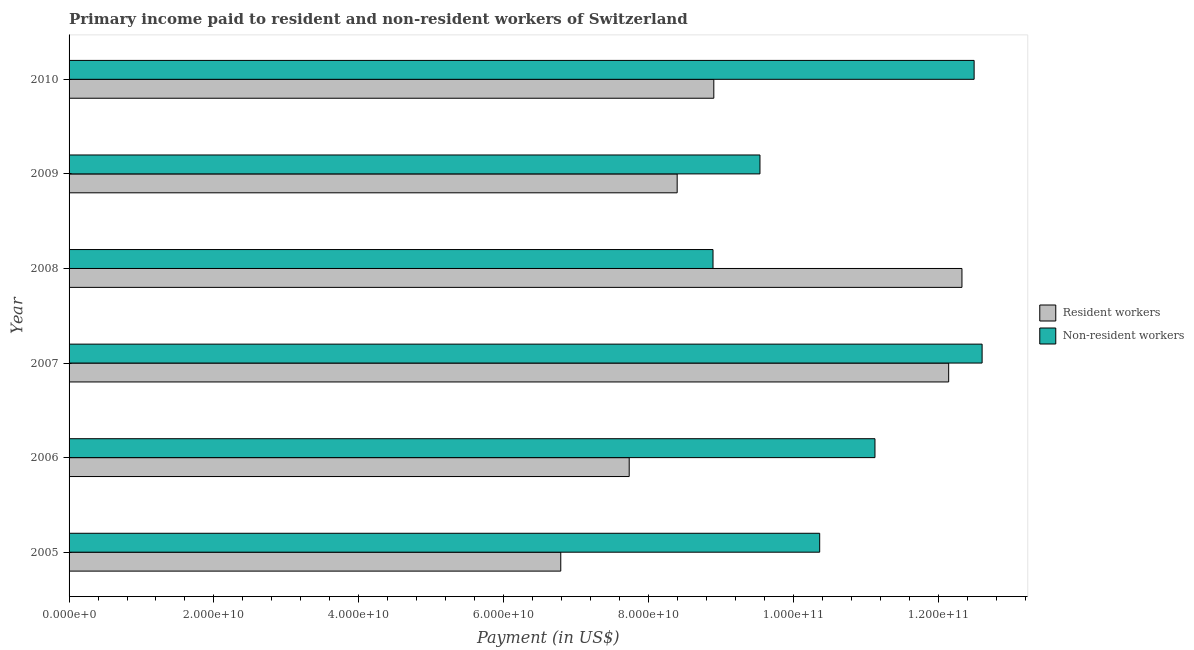How many different coloured bars are there?
Offer a terse response. 2. How many groups of bars are there?
Keep it short and to the point. 6. How many bars are there on the 5th tick from the top?
Your response must be concise. 2. What is the label of the 6th group of bars from the top?
Keep it short and to the point. 2005. What is the payment made to non-resident workers in 2008?
Provide a short and direct response. 8.89e+1. Across all years, what is the maximum payment made to resident workers?
Ensure brevity in your answer.  1.23e+11. Across all years, what is the minimum payment made to resident workers?
Your answer should be very brief. 6.79e+1. In which year was the payment made to non-resident workers maximum?
Ensure brevity in your answer.  2007. In which year was the payment made to resident workers minimum?
Give a very brief answer. 2005. What is the total payment made to non-resident workers in the graph?
Your answer should be very brief. 6.50e+11. What is the difference between the payment made to non-resident workers in 2007 and that in 2008?
Ensure brevity in your answer.  3.72e+1. What is the difference between the payment made to non-resident workers in 2006 and the payment made to resident workers in 2010?
Offer a very short reply. 2.22e+1. What is the average payment made to non-resident workers per year?
Keep it short and to the point. 1.08e+11. In the year 2006, what is the difference between the payment made to resident workers and payment made to non-resident workers?
Your response must be concise. -3.39e+1. In how many years, is the payment made to resident workers greater than 28000000000 US$?
Make the answer very short. 6. What is the ratio of the payment made to resident workers in 2006 to that in 2008?
Keep it short and to the point. 0.63. Is the difference between the payment made to non-resident workers in 2005 and 2007 greater than the difference between the payment made to resident workers in 2005 and 2007?
Provide a short and direct response. Yes. What is the difference between the highest and the second highest payment made to non-resident workers?
Offer a very short reply. 1.10e+09. What is the difference between the highest and the lowest payment made to non-resident workers?
Your answer should be very brief. 3.72e+1. What does the 2nd bar from the top in 2006 represents?
Offer a very short reply. Resident workers. What does the 1st bar from the bottom in 2009 represents?
Your answer should be very brief. Resident workers. How many bars are there?
Keep it short and to the point. 12. Are all the bars in the graph horizontal?
Provide a short and direct response. Yes. Does the graph contain any zero values?
Offer a terse response. No. Does the graph contain grids?
Make the answer very short. No. How many legend labels are there?
Your answer should be compact. 2. How are the legend labels stacked?
Your answer should be compact. Vertical. What is the title of the graph?
Keep it short and to the point. Primary income paid to resident and non-resident workers of Switzerland. What is the label or title of the X-axis?
Provide a succinct answer. Payment (in US$). What is the Payment (in US$) in Resident workers in 2005?
Provide a succinct answer. 6.79e+1. What is the Payment (in US$) of Non-resident workers in 2005?
Keep it short and to the point. 1.04e+11. What is the Payment (in US$) in Resident workers in 2006?
Your response must be concise. 7.73e+1. What is the Payment (in US$) in Non-resident workers in 2006?
Ensure brevity in your answer.  1.11e+11. What is the Payment (in US$) of Resident workers in 2007?
Provide a succinct answer. 1.21e+11. What is the Payment (in US$) in Non-resident workers in 2007?
Keep it short and to the point. 1.26e+11. What is the Payment (in US$) in Resident workers in 2008?
Your answer should be compact. 1.23e+11. What is the Payment (in US$) of Non-resident workers in 2008?
Keep it short and to the point. 8.89e+1. What is the Payment (in US$) in Resident workers in 2009?
Your response must be concise. 8.40e+1. What is the Payment (in US$) in Non-resident workers in 2009?
Provide a succinct answer. 9.54e+1. What is the Payment (in US$) of Resident workers in 2010?
Ensure brevity in your answer.  8.90e+1. What is the Payment (in US$) of Non-resident workers in 2010?
Your answer should be very brief. 1.25e+11. Across all years, what is the maximum Payment (in US$) of Resident workers?
Provide a short and direct response. 1.23e+11. Across all years, what is the maximum Payment (in US$) in Non-resident workers?
Ensure brevity in your answer.  1.26e+11. Across all years, what is the minimum Payment (in US$) in Resident workers?
Your answer should be compact. 6.79e+1. Across all years, what is the minimum Payment (in US$) in Non-resident workers?
Keep it short and to the point. 8.89e+1. What is the total Payment (in US$) in Resident workers in the graph?
Give a very brief answer. 5.63e+11. What is the total Payment (in US$) in Non-resident workers in the graph?
Offer a very short reply. 6.50e+11. What is the difference between the Payment (in US$) in Resident workers in 2005 and that in 2006?
Your answer should be compact. -9.45e+09. What is the difference between the Payment (in US$) in Non-resident workers in 2005 and that in 2006?
Ensure brevity in your answer.  -7.63e+09. What is the difference between the Payment (in US$) in Resident workers in 2005 and that in 2007?
Provide a succinct answer. -5.36e+1. What is the difference between the Payment (in US$) in Non-resident workers in 2005 and that in 2007?
Your answer should be very brief. -2.24e+1. What is the difference between the Payment (in US$) in Resident workers in 2005 and that in 2008?
Your response must be concise. -5.54e+1. What is the difference between the Payment (in US$) of Non-resident workers in 2005 and that in 2008?
Your response must be concise. 1.47e+1. What is the difference between the Payment (in US$) of Resident workers in 2005 and that in 2009?
Your response must be concise. -1.61e+1. What is the difference between the Payment (in US$) in Non-resident workers in 2005 and that in 2009?
Ensure brevity in your answer.  8.24e+09. What is the difference between the Payment (in US$) of Resident workers in 2005 and that in 2010?
Provide a succinct answer. -2.11e+1. What is the difference between the Payment (in US$) in Non-resident workers in 2005 and that in 2010?
Provide a short and direct response. -2.13e+1. What is the difference between the Payment (in US$) of Resident workers in 2006 and that in 2007?
Keep it short and to the point. -4.41e+1. What is the difference between the Payment (in US$) in Non-resident workers in 2006 and that in 2007?
Your response must be concise. -1.48e+1. What is the difference between the Payment (in US$) of Resident workers in 2006 and that in 2008?
Keep it short and to the point. -4.59e+1. What is the difference between the Payment (in US$) of Non-resident workers in 2006 and that in 2008?
Keep it short and to the point. 2.24e+1. What is the difference between the Payment (in US$) of Resident workers in 2006 and that in 2009?
Ensure brevity in your answer.  -6.62e+09. What is the difference between the Payment (in US$) in Non-resident workers in 2006 and that in 2009?
Give a very brief answer. 1.59e+1. What is the difference between the Payment (in US$) of Resident workers in 2006 and that in 2010?
Provide a short and direct response. -1.17e+1. What is the difference between the Payment (in US$) in Non-resident workers in 2006 and that in 2010?
Offer a terse response. -1.37e+1. What is the difference between the Payment (in US$) in Resident workers in 2007 and that in 2008?
Offer a very short reply. -1.83e+09. What is the difference between the Payment (in US$) in Non-resident workers in 2007 and that in 2008?
Give a very brief answer. 3.72e+1. What is the difference between the Payment (in US$) of Resident workers in 2007 and that in 2009?
Ensure brevity in your answer.  3.75e+1. What is the difference between the Payment (in US$) in Non-resident workers in 2007 and that in 2009?
Offer a terse response. 3.07e+1. What is the difference between the Payment (in US$) of Resident workers in 2007 and that in 2010?
Give a very brief answer. 3.24e+1. What is the difference between the Payment (in US$) in Non-resident workers in 2007 and that in 2010?
Offer a terse response. 1.10e+09. What is the difference between the Payment (in US$) of Resident workers in 2008 and that in 2009?
Provide a short and direct response. 3.93e+1. What is the difference between the Payment (in US$) of Non-resident workers in 2008 and that in 2009?
Give a very brief answer. -6.48e+09. What is the difference between the Payment (in US$) of Resident workers in 2008 and that in 2010?
Keep it short and to the point. 3.43e+1. What is the difference between the Payment (in US$) of Non-resident workers in 2008 and that in 2010?
Give a very brief answer. -3.60e+1. What is the difference between the Payment (in US$) in Resident workers in 2009 and that in 2010?
Provide a short and direct response. -5.06e+09. What is the difference between the Payment (in US$) of Non-resident workers in 2009 and that in 2010?
Keep it short and to the point. -2.96e+1. What is the difference between the Payment (in US$) of Resident workers in 2005 and the Payment (in US$) of Non-resident workers in 2006?
Provide a short and direct response. -4.34e+1. What is the difference between the Payment (in US$) of Resident workers in 2005 and the Payment (in US$) of Non-resident workers in 2007?
Make the answer very short. -5.82e+1. What is the difference between the Payment (in US$) in Resident workers in 2005 and the Payment (in US$) in Non-resident workers in 2008?
Your answer should be very brief. -2.10e+1. What is the difference between the Payment (in US$) of Resident workers in 2005 and the Payment (in US$) of Non-resident workers in 2009?
Your answer should be compact. -2.75e+1. What is the difference between the Payment (in US$) of Resident workers in 2005 and the Payment (in US$) of Non-resident workers in 2010?
Make the answer very short. -5.71e+1. What is the difference between the Payment (in US$) of Resident workers in 2006 and the Payment (in US$) of Non-resident workers in 2007?
Provide a succinct answer. -4.87e+1. What is the difference between the Payment (in US$) in Resident workers in 2006 and the Payment (in US$) in Non-resident workers in 2008?
Provide a succinct answer. -1.16e+1. What is the difference between the Payment (in US$) in Resident workers in 2006 and the Payment (in US$) in Non-resident workers in 2009?
Keep it short and to the point. -1.81e+1. What is the difference between the Payment (in US$) of Resident workers in 2006 and the Payment (in US$) of Non-resident workers in 2010?
Give a very brief answer. -4.76e+1. What is the difference between the Payment (in US$) in Resident workers in 2007 and the Payment (in US$) in Non-resident workers in 2008?
Make the answer very short. 3.25e+1. What is the difference between the Payment (in US$) in Resident workers in 2007 and the Payment (in US$) in Non-resident workers in 2009?
Give a very brief answer. 2.61e+1. What is the difference between the Payment (in US$) in Resident workers in 2007 and the Payment (in US$) in Non-resident workers in 2010?
Make the answer very short. -3.51e+09. What is the difference between the Payment (in US$) in Resident workers in 2008 and the Payment (in US$) in Non-resident workers in 2009?
Make the answer very short. 2.79e+1. What is the difference between the Payment (in US$) of Resident workers in 2008 and the Payment (in US$) of Non-resident workers in 2010?
Make the answer very short. -1.68e+09. What is the difference between the Payment (in US$) of Resident workers in 2009 and the Payment (in US$) of Non-resident workers in 2010?
Provide a short and direct response. -4.10e+1. What is the average Payment (in US$) of Resident workers per year?
Keep it short and to the point. 9.38e+1. What is the average Payment (in US$) in Non-resident workers per year?
Offer a terse response. 1.08e+11. In the year 2005, what is the difference between the Payment (in US$) of Resident workers and Payment (in US$) of Non-resident workers?
Provide a succinct answer. -3.57e+1. In the year 2006, what is the difference between the Payment (in US$) in Resident workers and Payment (in US$) in Non-resident workers?
Make the answer very short. -3.39e+1. In the year 2007, what is the difference between the Payment (in US$) in Resident workers and Payment (in US$) in Non-resident workers?
Provide a short and direct response. -4.62e+09. In the year 2008, what is the difference between the Payment (in US$) of Resident workers and Payment (in US$) of Non-resident workers?
Keep it short and to the point. 3.44e+1. In the year 2009, what is the difference between the Payment (in US$) of Resident workers and Payment (in US$) of Non-resident workers?
Your answer should be compact. -1.14e+1. In the year 2010, what is the difference between the Payment (in US$) of Resident workers and Payment (in US$) of Non-resident workers?
Offer a very short reply. -3.59e+1. What is the ratio of the Payment (in US$) in Resident workers in 2005 to that in 2006?
Give a very brief answer. 0.88. What is the ratio of the Payment (in US$) in Non-resident workers in 2005 to that in 2006?
Provide a succinct answer. 0.93. What is the ratio of the Payment (in US$) in Resident workers in 2005 to that in 2007?
Provide a short and direct response. 0.56. What is the ratio of the Payment (in US$) in Non-resident workers in 2005 to that in 2007?
Provide a succinct answer. 0.82. What is the ratio of the Payment (in US$) of Resident workers in 2005 to that in 2008?
Make the answer very short. 0.55. What is the ratio of the Payment (in US$) in Non-resident workers in 2005 to that in 2008?
Your response must be concise. 1.17. What is the ratio of the Payment (in US$) in Resident workers in 2005 to that in 2009?
Ensure brevity in your answer.  0.81. What is the ratio of the Payment (in US$) of Non-resident workers in 2005 to that in 2009?
Make the answer very short. 1.09. What is the ratio of the Payment (in US$) of Resident workers in 2005 to that in 2010?
Make the answer very short. 0.76. What is the ratio of the Payment (in US$) in Non-resident workers in 2005 to that in 2010?
Offer a very short reply. 0.83. What is the ratio of the Payment (in US$) in Resident workers in 2006 to that in 2007?
Your answer should be compact. 0.64. What is the ratio of the Payment (in US$) in Non-resident workers in 2006 to that in 2007?
Your answer should be very brief. 0.88. What is the ratio of the Payment (in US$) of Resident workers in 2006 to that in 2008?
Offer a terse response. 0.63. What is the ratio of the Payment (in US$) in Non-resident workers in 2006 to that in 2008?
Provide a succinct answer. 1.25. What is the ratio of the Payment (in US$) of Resident workers in 2006 to that in 2009?
Keep it short and to the point. 0.92. What is the ratio of the Payment (in US$) of Non-resident workers in 2006 to that in 2009?
Keep it short and to the point. 1.17. What is the ratio of the Payment (in US$) of Resident workers in 2006 to that in 2010?
Offer a very short reply. 0.87. What is the ratio of the Payment (in US$) of Non-resident workers in 2006 to that in 2010?
Make the answer very short. 0.89. What is the ratio of the Payment (in US$) of Resident workers in 2007 to that in 2008?
Offer a very short reply. 0.99. What is the ratio of the Payment (in US$) of Non-resident workers in 2007 to that in 2008?
Give a very brief answer. 1.42. What is the ratio of the Payment (in US$) of Resident workers in 2007 to that in 2009?
Give a very brief answer. 1.45. What is the ratio of the Payment (in US$) of Non-resident workers in 2007 to that in 2009?
Your response must be concise. 1.32. What is the ratio of the Payment (in US$) of Resident workers in 2007 to that in 2010?
Make the answer very short. 1.36. What is the ratio of the Payment (in US$) of Non-resident workers in 2007 to that in 2010?
Keep it short and to the point. 1.01. What is the ratio of the Payment (in US$) in Resident workers in 2008 to that in 2009?
Offer a terse response. 1.47. What is the ratio of the Payment (in US$) in Non-resident workers in 2008 to that in 2009?
Keep it short and to the point. 0.93. What is the ratio of the Payment (in US$) in Resident workers in 2008 to that in 2010?
Your answer should be compact. 1.38. What is the ratio of the Payment (in US$) in Non-resident workers in 2008 to that in 2010?
Your answer should be compact. 0.71. What is the ratio of the Payment (in US$) of Resident workers in 2009 to that in 2010?
Your answer should be compact. 0.94. What is the ratio of the Payment (in US$) in Non-resident workers in 2009 to that in 2010?
Make the answer very short. 0.76. What is the difference between the highest and the second highest Payment (in US$) in Resident workers?
Provide a succinct answer. 1.83e+09. What is the difference between the highest and the second highest Payment (in US$) in Non-resident workers?
Provide a succinct answer. 1.10e+09. What is the difference between the highest and the lowest Payment (in US$) in Resident workers?
Keep it short and to the point. 5.54e+1. What is the difference between the highest and the lowest Payment (in US$) in Non-resident workers?
Provide a succinct answer. 3.72e+1. 